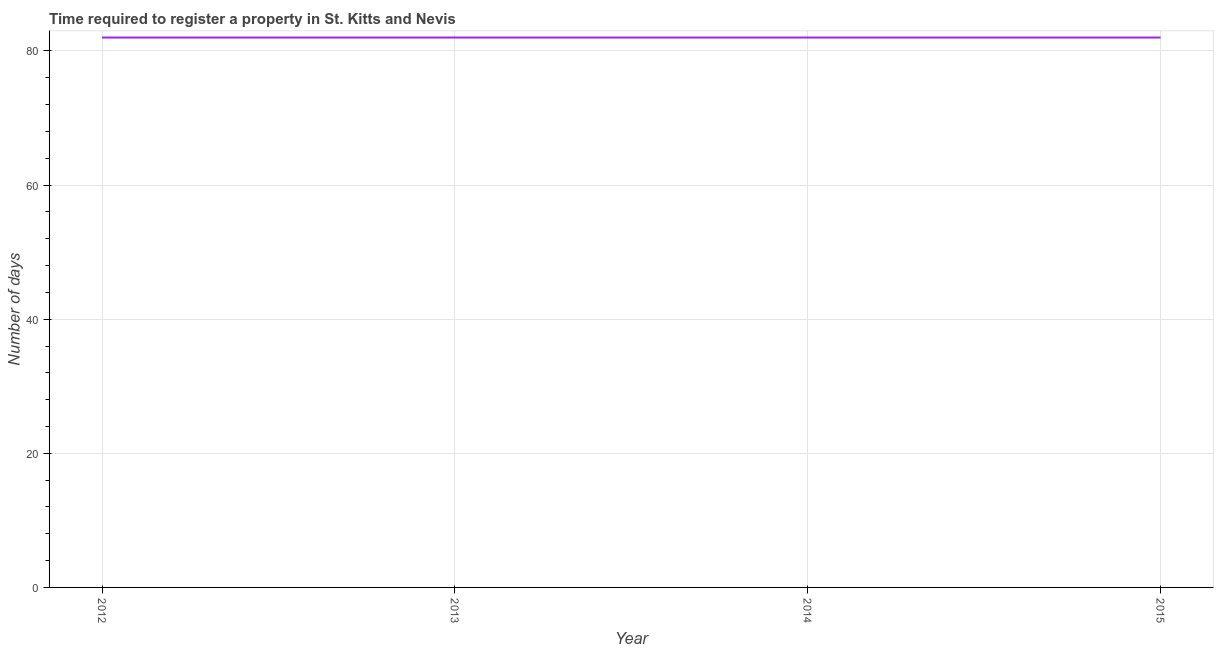What is the number of days required to register property in 2014?
Your answer should be compact. 82. Across all years, what is the maximum number of days required to register property?
Your answer should be very brief. 82. Across all years, what is the minimum number of days required to register property?
Make the answer very short. 82. In which year was the number of days required to register property minimum?
Give a very brief answer. 2012. What is the sum of the number of days required to register property?
Keep it short and to the point. 328. What is the ratio of the number of days required to register property in 2013 to that in 2014?
Your response must be concise. 1. What is the difference between the highest and the second highest number of days required to register property?
Ensure brevity in your answer.  0. Is the sum of the number of days required to register property in 2012 and 2013 greater than the maximum number of days required to register property across all years?
Keep it short and to the point. Yes. Does the number of days required to register property monotonically increase over the years?
Offer a very short reply. No. How many years are there in the graph?
Your answer should be compact. 4. Are the values on the major ticks of Y-axis written in scientific E-notation?
Your answer should be very brief. No. What is the title of the graph?
Ensure brevity in your answer.  Time required to register a property in St. Kitts and Nevis. What is the label or title of the Y-axis?
Your answer should be very brief. Number of days. What is the Number of days of 2012?
Ensure brevity in your answer.  82. What is the Number of days of 2013?
Ensure brevity in your answer.  82. What is the Number of days in 2015?
Provide a succinct answer. 82. What is the difference between the Number of days in 2012 and 2014?
Give a very brief answer. 0. What is the difference between the Number of days in 2013 and 2014?
Give a very brief answer. 0. What is the difference between the Number of days in 2014 and 2015?
Offer a terse response. 0. What is the ratio of the Number of days in 2012 to that in 2013?
Offer a very short reply. 1. What is the ratio of the Number of days in 2012 to that in 2015?
Ensure brevity in your answer.  1. What is the ratio of the Number of days in 2013 to that in 2014?
Your response must be concise. 1. 